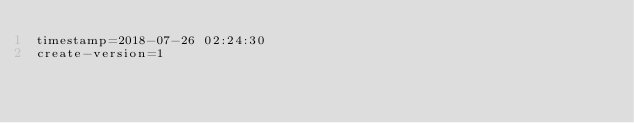<code> <loc_0><loc_0><loc_500><loc_500><_VisualBasic_>timestamp=2018-07-26 02:24:30
create-version=1</code> 